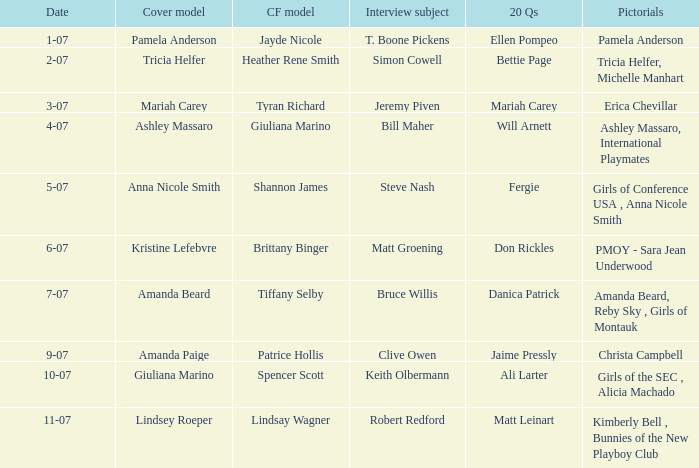Who answered the 20 questions on 10-07? Ali Larter. 